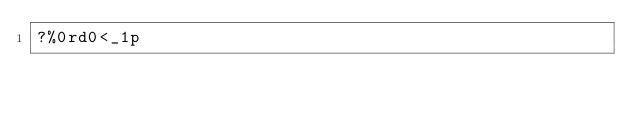Convert code to text. <code><loc_0><loc_0><loc_500><loc_500><_dc_>?%0rd0<_1p</code> 